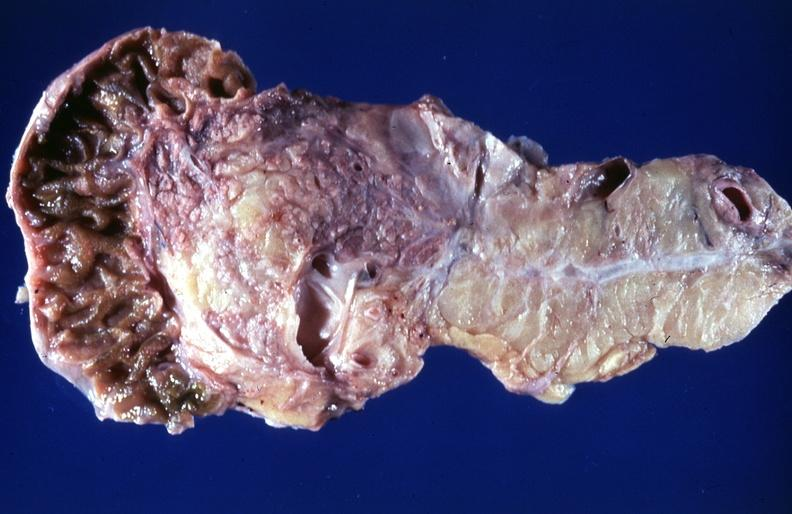what is present?
Answer the question using a single word or phrase. Pancreas 